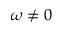Convert formula to latex. <formula><loc_0><loc_0><loc_500><loc_500>\omega \ne 0</formula> 